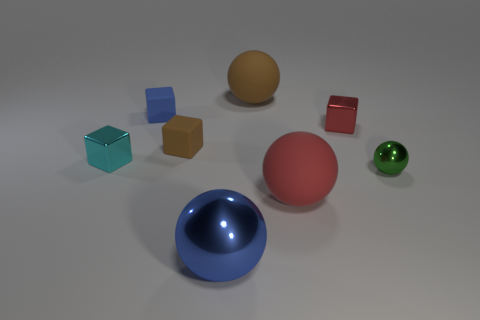How many objects are spheres that are behind the tiny cyan metallic object or objects that are to the left of the red metal object?
Your answer should be very brief. 6. Are there any other things that have the same color as the small shiny ball?
Offer a terse response. No. Are there the same number of small green objects that are in front of the big blue metallic sphere and objects that are on the left side of the tiny red object?
Provide a short and direct response. No. Is the number of small things to the right of the blue rubber thing greater than the number of tiny green metal things?
Your response must be concise. Yes. What number of things are either big brown matte spheres that are on the right side of the large blue ball or tiny objects?
Give a very brief answer. 6. What number of tiny spheres have the same material as the large blue sphere?
Your answer should be compact. 1. Are there any tiny brown things that have the same shape as the large brown matte object?
Provide a short and direct response. No. What shape is the green object that is the same size as the red metallic block?
Your response must be concise. Sphere. There is a big metal sphere; is its color the same as the tiny matte object that is left of the brown rubber block?
Your answer should be compact. Yes. There is a big matte sphere behind the small cyan object; how many red balls are right of it?
Ensure brevity in your answer.  1. 